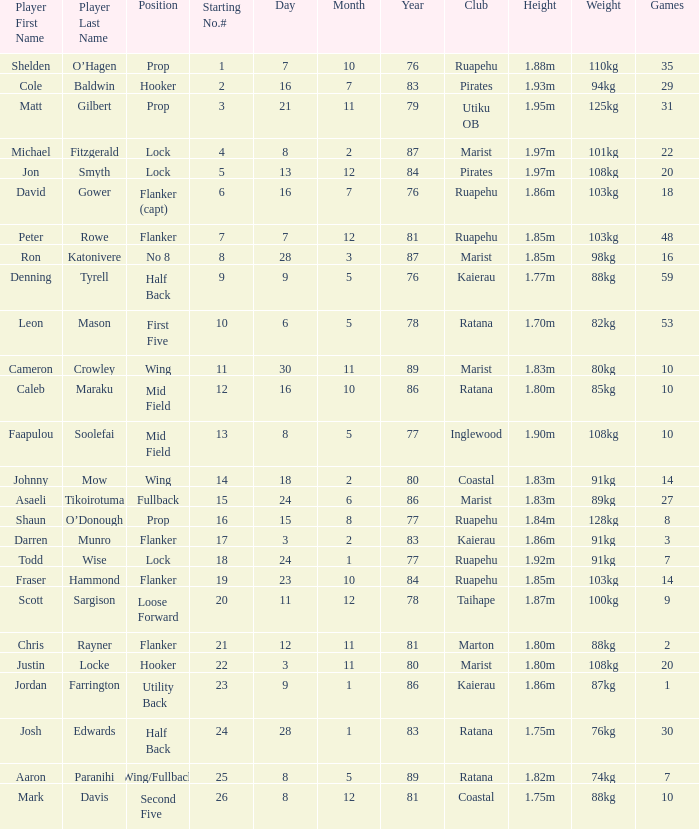What placement does the competitor todd wise occupy in? Lock. 